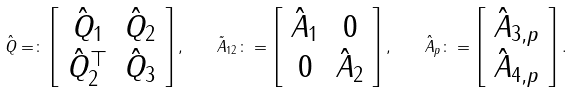Convert formula to latex. <formula><loc_0><loc_0><loc_500><loc_500>\hat { Q } = \colon \left [ \begin{array} { c c } \hat { Q } _ { 1 } & \hat { Q } _ { 2 } \\ \hat { Q } _ { 2 } ^ { \top } & \hat { Q } _ { 3 } \end{array} \right ] , \quad \tilde { A } _ { 1 2 } \colon = \left [ \begin{array} { c c } \hat { A } _ { 1 } & 0 \\ 0 & \hat { A } _ { 2 } \end{array} \right ] , \quad \hat { A } _ { p } \colon = \left [ \begin{array} { c } \hat { A } _ { 3 , p } \\ \hat { A } _ { 4 , p } \end{array} \right ] .</formula> 